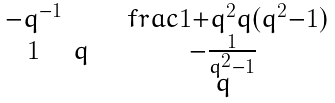<formula> <loc_0><loc_0><loc_500><loc_500>\begin{smallmatrix} - q ^ { - 1 } & & \ \ \ f r a c { 1 + q ^ { 2 } } { q ( q ^ { 2 } - 1 ) } \\ 1 & q & \ \ - \frac { 1 } { q ^ { 2 } - 1 } \\ & & \ \ q \end{smallmatrix}</formula> 